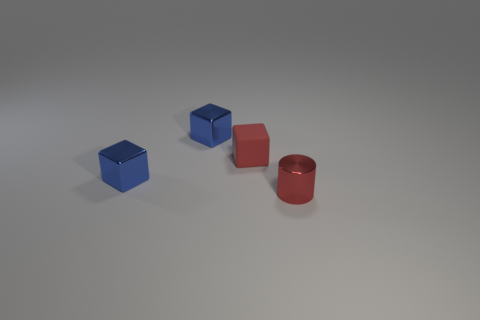What number of things are there?
Provide a succinct answer. 4. Do the red cylinder and the rubber object have the same size?
Keep it short and to the point. Yes. Is there a metal object that has the same color as the tiny matte cube?
Make the answer very short. Yes. There is a red thing behind the tiny red cylinder; is it the same shape as the tiny red metal thing?
Keep it short and to the point. No. What number of red rubber objects have the same size as the red cylinder?
Offer a very short reply. 1. What number of tiny red rubber cubes are behind the tiny red thing that is behind the small cylinder?
Your response must be concise. 0. Is the material of the blue object in front of the small red rubber thing the same as the cylinder?
Offer a terse response. Yes. Do the tiny red thing that is on the right side of the rubber thing and the tiny blue object in front of the small red block have the same material?
Provide a succinct answer. Yes. Is the number of small blue blocks behind the small red metallic thing greater than the number of red matte things?
Your answer should be very brief. Yes. What color is the cube behind the red thing that is on the left side of the red shiny thing?
Keep it short and to the point. Blue. 